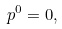Convert formula to latex. <formula><loc_0><loc_0><loc_500><loc_500>p ^ { 0 } = 0 ,</formula> 